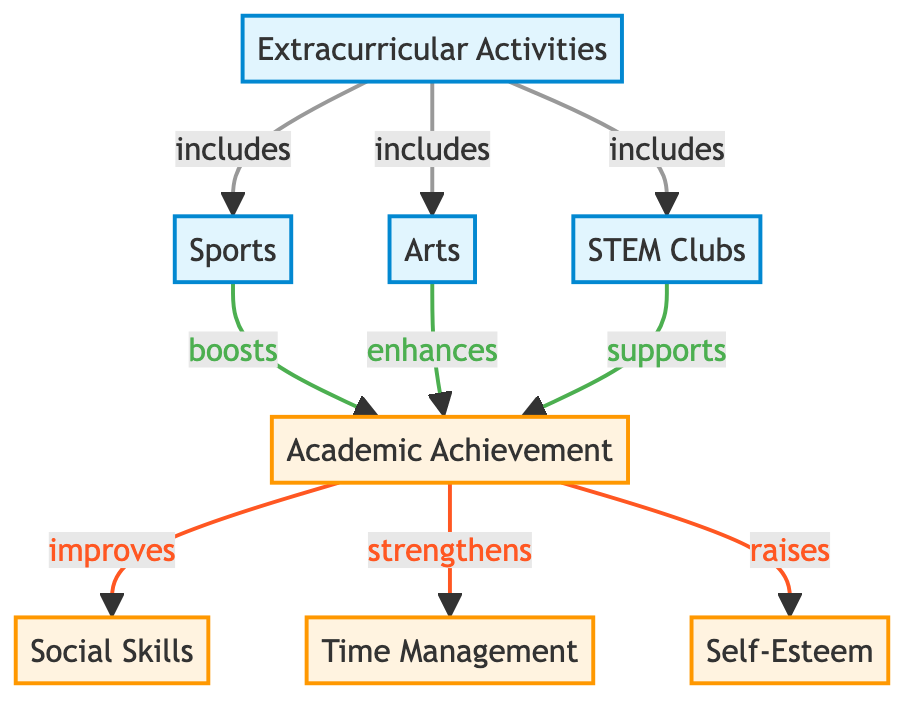What are the three types of extracurricular activities listed? The diagram categorizes three types of extracurricular activities: Sports, Arts, and STEM Clubs. These are directly shown as nodes connected to the Extracurricular Activities node.
Answer: Sports, Arts, STEM Clubs How many outcomes are associated with Academic Achievement? The diagram shows three outcomes that are influenced by Academic Achievement: Social Skills, Time Management, and Self-Esteem. This can be seen where the Academic Achievement node connects to these three outcome nodes.
Answer: 3 What is the relationship between Sports and Academic Achievement? The diagram specifies that Sports "boosts" Academic Achievement. This relationship is indicated by the directional arrow connecting the Sports node to the Academic Achievement node with the label "boosts."
Answer: boosts Which extracurricular activity supports Academic Achievement? According to the diagram, STEM Clubs support Academic Achievement. This can be determined by following the arrow from the STEM Clubs node to the Academic Achievement node, where it is labeled "supports."
Answer: supports What do the outcomes Social Skills and Self-Esteem have in common? Both Social Skills and Self-Esteem are outcomes that are influenced by Academic Achievement. This relationship is shown by the arrows pointing from Academic Achievement to both outcome nodes.
Answer: influenced by Academic Achievement Which type of extracurricular activity enhances Academic Achievement? The diagram indicates that Arts enhances Academic Achievement. This is seen through the connection from the Arts node to the Academic Achievement node with the descriptor "enhances."
Answer: enhances How many total nodes are present in the diagram? The diagram contains eight nodes in total: one for Extracurricular Activities, three for types of activities (Sports, Arts, STEM Clubs), and four for outcomes (Academic Achievement, Social Skills, Time Management, Self-Esteem). By counting all these nodes, we find the total.
Answer: 8 What is the first node in the hierarchy of the diagram? The first node is Extracurricular Activities, which is at the top of the diagram and serves as the starting point connecting to different types of activities.
Answer: Extracurricular Activities What is the action described between Academic Achievement and Time Management? The action is that Academic Achievement "strengthens" Time Management. This is indicated next to the arrow connecting the Academic Achievement node to the Time Management node.
Answer: strengthens 